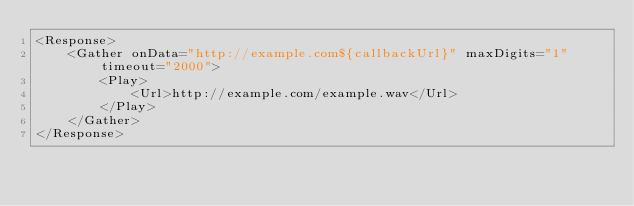<code> <loc_0><loc_0><loc_500><loc_500><_XML_><Response>
    <Gather onData="http://example.com${callbackUrl}" maxDigits="1" timeout="2000">
        <Play>
            <Url>http://example.com/example.wav</Url>
        </Play>
    </Gather>
</Response></code> 